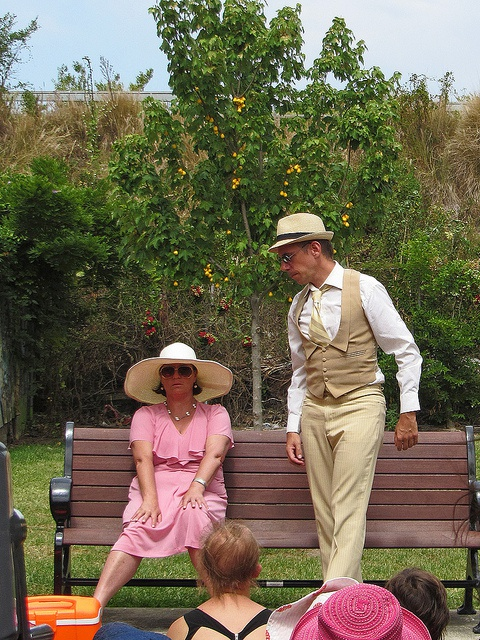Describe the objects in this image and their specific colors. I can see people in lavender, lightgray, tan, and gray tones, bench in lavender, brown, gray, black, and maroon tones, people in lavender, lightpink, brown, and maroon tones, people in lavender, black, maroon, gray, and tan tones, and people in lavender, violet, brown, and lightpink tones in this image. 